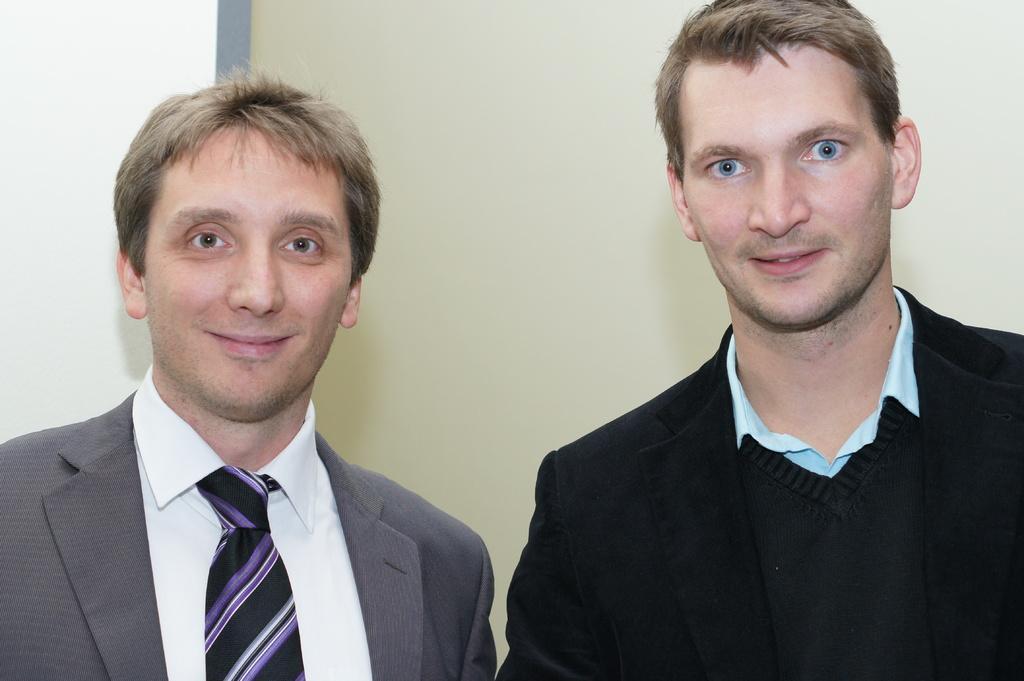Could you give a brief overview of what you see in this image? In this picture I can observe two men. Both of them are smiling. One of them is wearing a coat which is in grey color and the other is wearing black color coat. In the background there is a wall. 